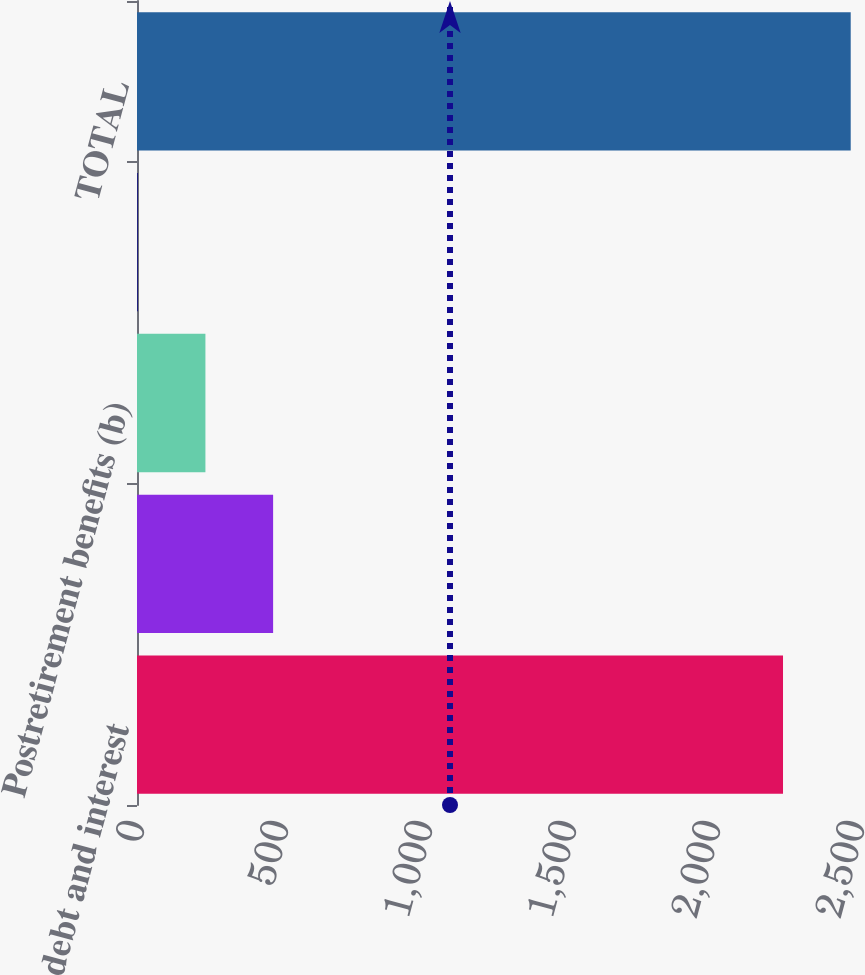Convert chart. <chart><loc_0><loc_0><loc_500><loc_500><bar_chart><fcel>Long-term debt and interest<fcel>Minimum operating lease<fcel>Postretirement benefits (b)<fcel>Purchase obligations (d)<fcel>TOTAL<nl><fcel>2243.1<fcel>472.64<fcel>237.57<fcel>2.5<fcel>2478.17<nl></chart> 